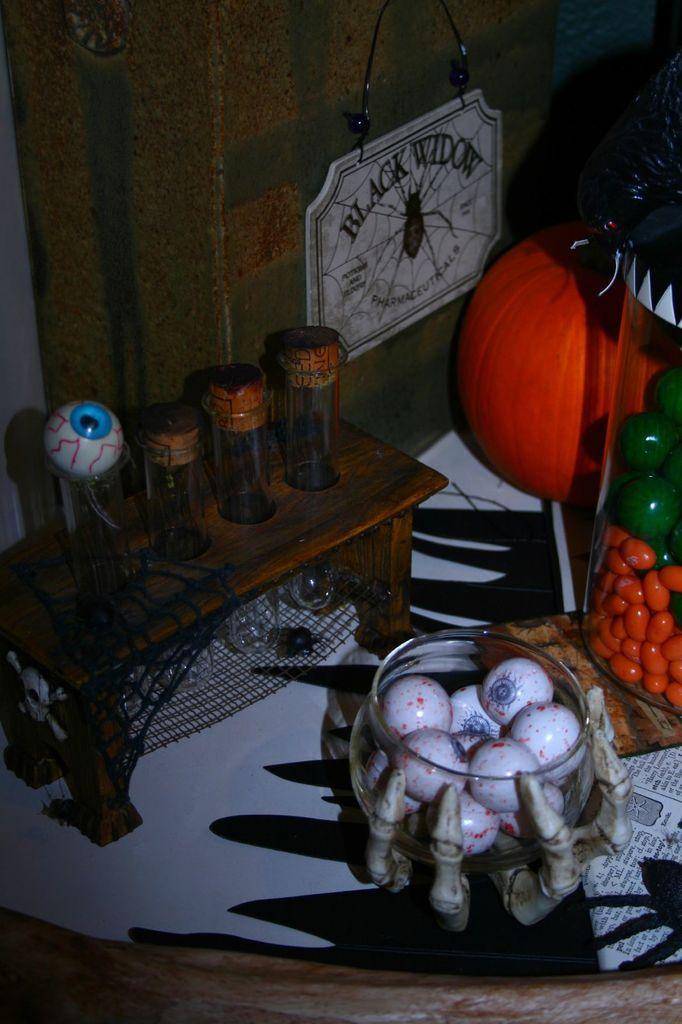Can you describe this image briefly? In this picture we can see bowl and this is a wooden table. 